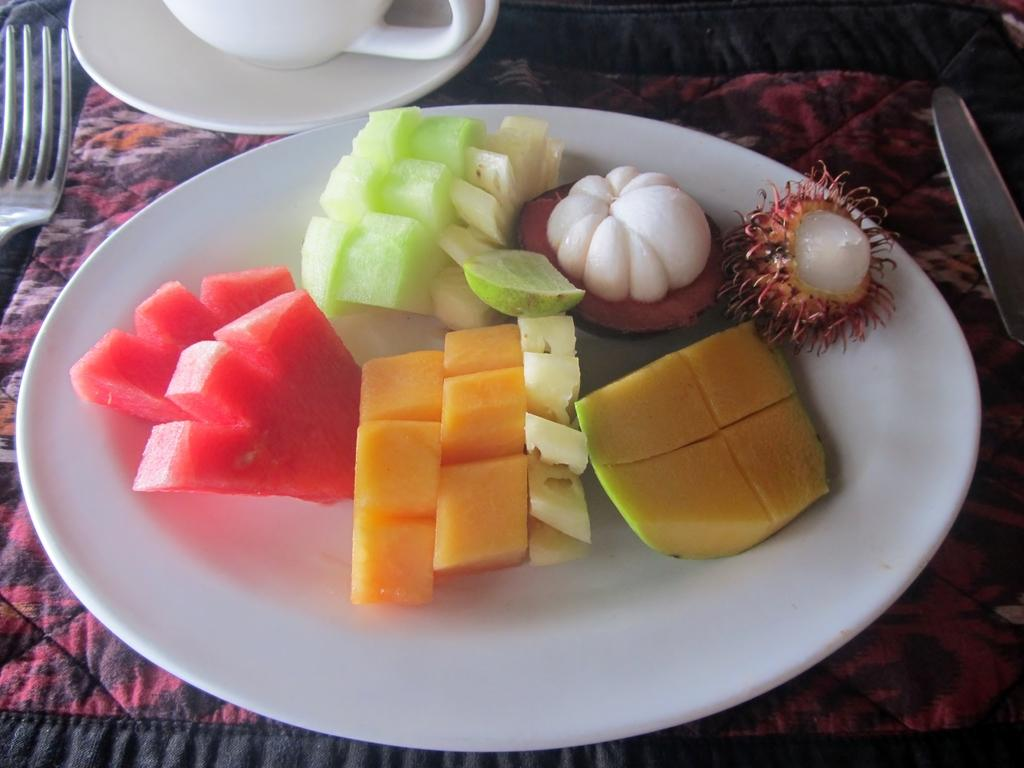What type of food is on the plate in the image? There is a plate containing cut fruits in the image. What type of container is present in the image? There is a cup in the image. What is the saucer used for in the image? The saucer is present in the image, likely to hold the cup. What utensils are visible in the image? There is a fork and a knife in the image. What is the surface on which the objects are placed? The objects are placed on a cloth. Where are the kittens playing in the image? There are no kittens present in the image. What type of waste is being disposed of in the image? There is no waste being disposed of in the image. 